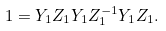Convert formula to latex. <formula><loc_0><loc_0><loc_500><loc_500>1 = Y _ { 1 } Z _ { 1 } Y _ { 1 } Z _ { 1 } ^ { - 1 } Y _ { 1 } Z _ { 1 } .</formula> 